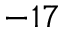Convert formula to latex. <formula><loc_0><loc_0><loc_500><loc_500>^ { - 1 7 }</formula> 